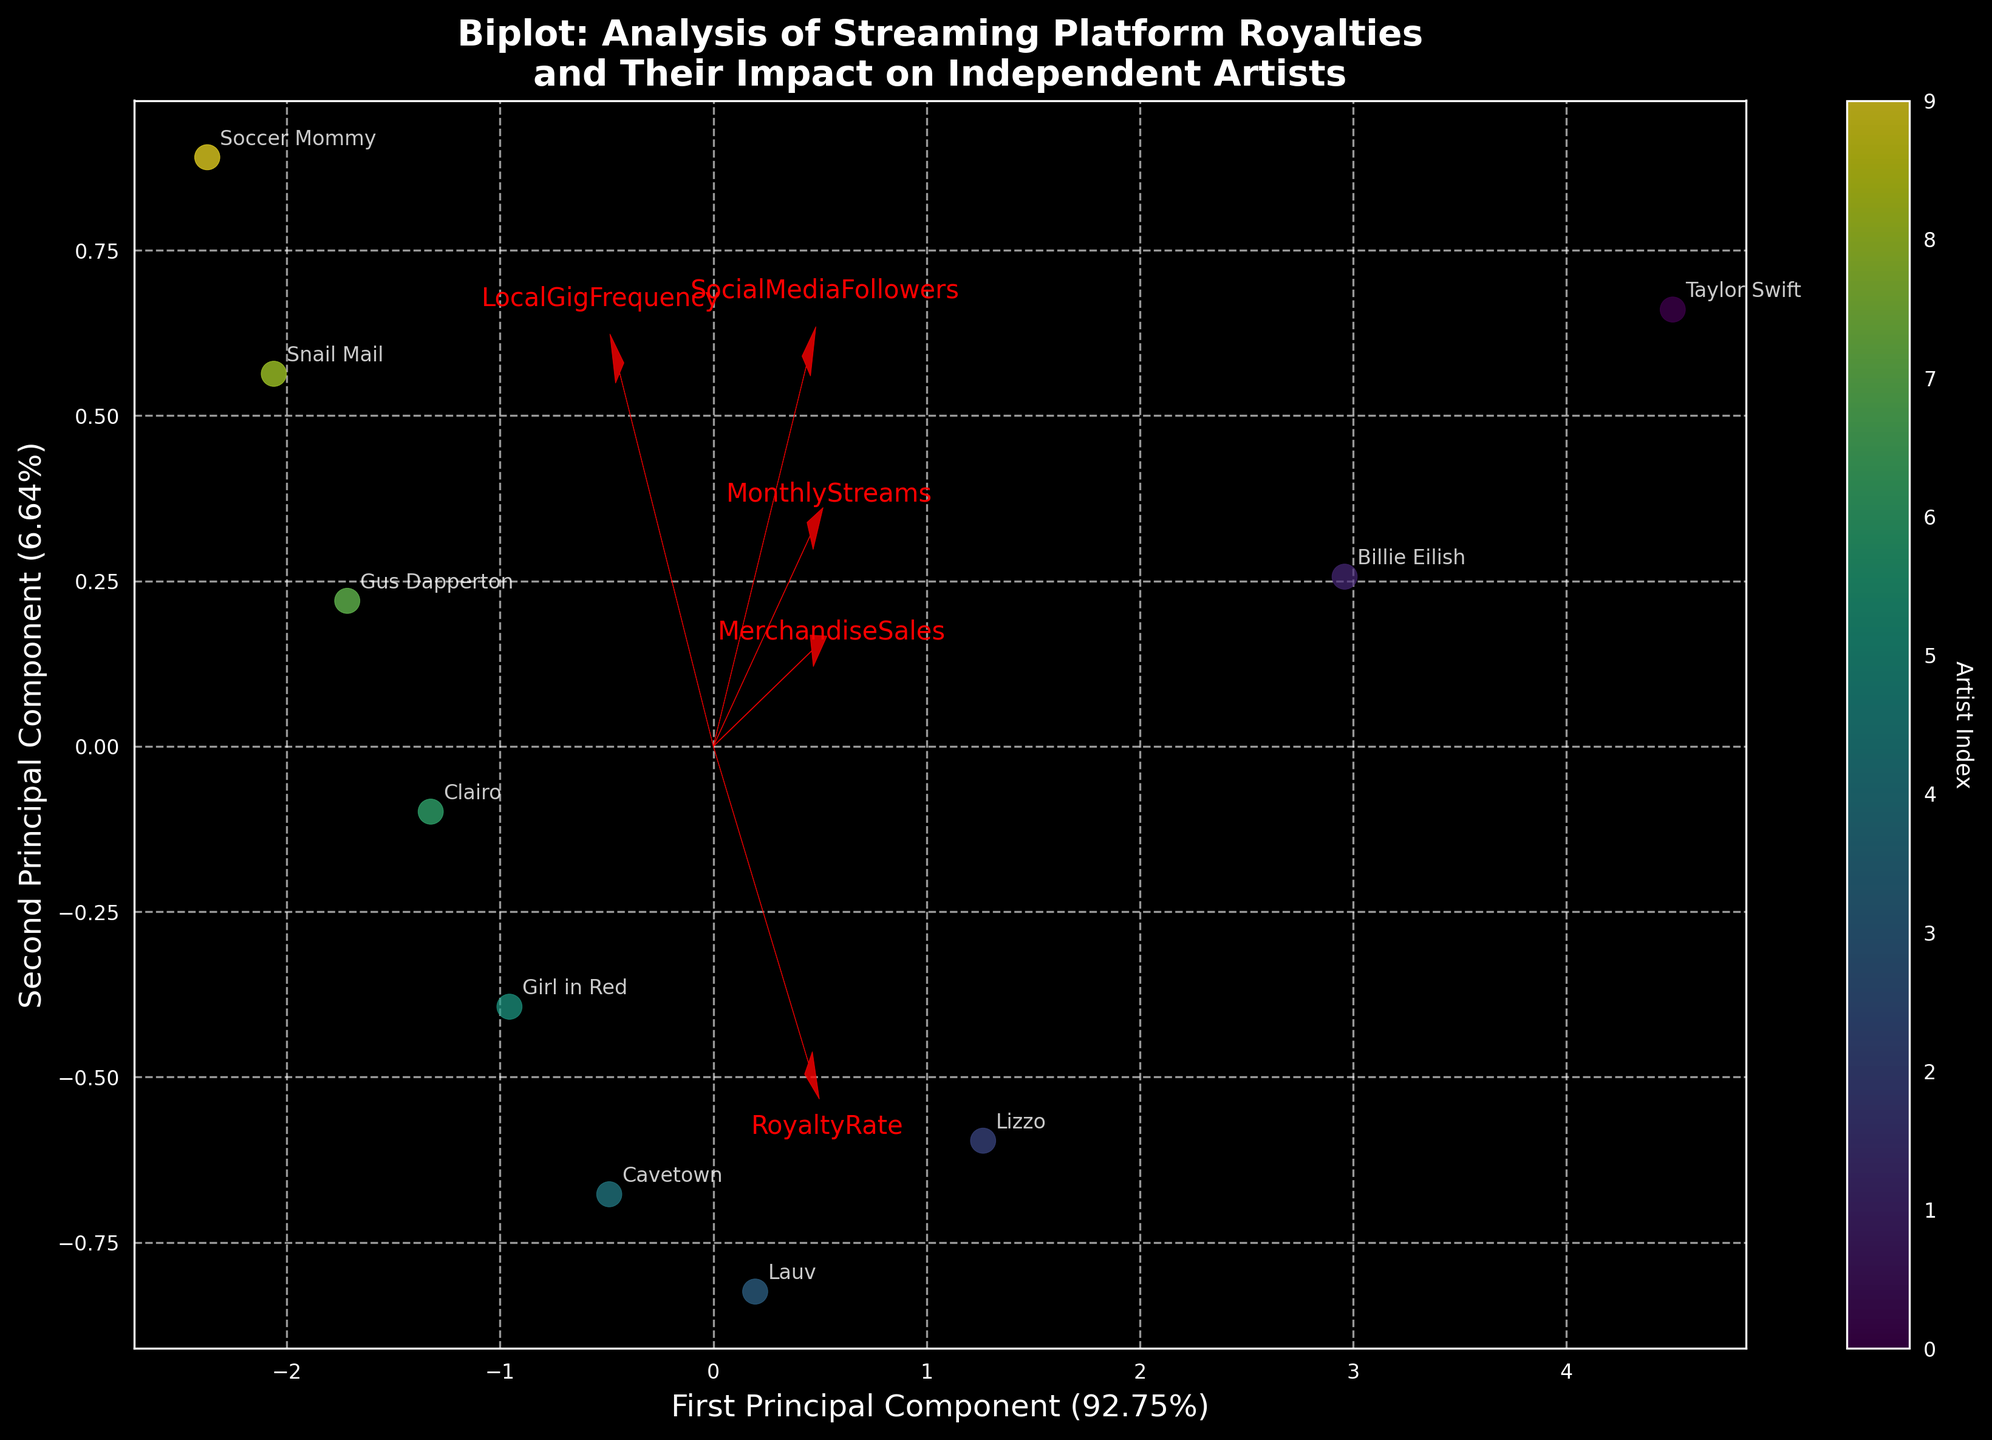What does the plotted figure analyze? The figure's title is "Biplot: Analysis of Streaming Platform Royalties and Their Impact on Independent Artists". It clearly indicates that the analysis focuses on how streaming royalties from platforms affect the income of independent artists.
Answer: Streaming royalties and artists' income How many principal components are shown in the biplot? The axes are labeled "First Principal Component" and "Second Principal Component", showing that two principal components are presented in the biplot.
Answer: Two Which artist has the highest MonthlyStreams according to the biplot? The biplot shows the transformed data points with annotations. Taylor Swift, positioned farthest in the direction where "MonthlyStreams" feature vector points, has the highest MonthlyStreams.
Answer: Taylor Swift Which feature vector appears to have the smallest contribution to the first principal component? By comparing the length and direction of the feature arrows, "RoyaltyRate" appears shortest in the direction of the first principal component, indicating a smaller contribution.
Answer: RoyaltyRate What is the direction of the "MerchandiseSales" feature vector? The "MerchandiseSales" vector points towards the top right quadrant of the biplot, indicating a positive contribution to both principal components.
Answer: Top right quadrant Are higher values of "SocialMediaFollowers" associated with higher principal component one scores? The "SocialMediaFollowers" vector points to the right, aligning with the positive direction on the first principal component axis, suggesting higher values of "SocialMediaFollowers" associate with higher first principal component scores.
Answer: Yes Which artist appears to have the highest LocalGigFrequency according to the plot? Gus Dapperton, marked near the end of the "LocalGigFrequency" vector's direction, appears to have the highest LocalGigFrequency.
Answer: Gus Dapperton Do any of the artists cluster closely together in the biplot? In the biplot, Clairo and Gus Dapperton are positioned closely together, suggesting similar profiles in the analyzed features.
Answer: Clairo and Gus Dapperton Which feature seems to most strongly influence the second principal component? The "LocalGigFrequency" vector points mostly along the y-axis representing the second principal component and is the longest, indicating the strongest influence.
Answer: LocalGigFrequency 